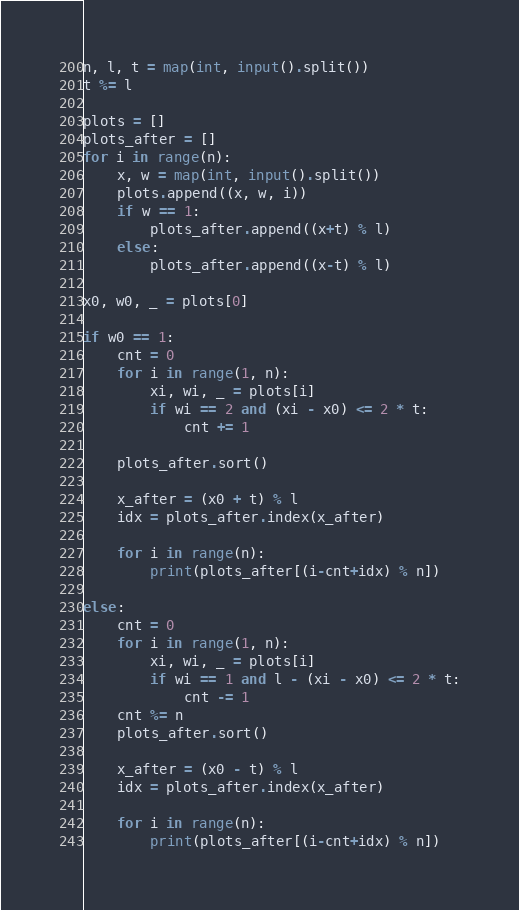Convert code to text. <code><loc_0><loc_0><loc_500><loc_500><_Python_>n, l, t = map(int, input().split())
t %= l

plots = []
plots_after = []
for i in range(n):
    x, w = map(int, input().split())
    plots.append((x, w, i))
    if w == 1:
        plots_after.append((x+t) % l)
    else:
        plots_after.append((x-t) % l)
    
x0, w0, _ = plots[0]

if w0 == 1:
    cnt = 0
    for i in range(1, n):
        xi, wi, _ = plots[i]
        if wi == 2 and (xi - x0) <= 2 * t:
            cnt += 1

    plots_after.sort()

    x_after = (x0 + t) % l
    idx = plots_after.index(x_after)

    for i in range(n):
        print(plots_after[(i-cnt+idx) % n])

else:
    cnt = 0
    for i in range(1, n):
        xi, wi, _ = plots[i]
        if wi == 1 and l - (xi - x0) <= 2 * t:
            cnt -= 1
    cnt %= n
    plots_after.sort()

    x_after = (x0 - t) % l
    idx = plots_after.index(x_after)

    for i in range(n):
        print(plots_after[(i-cnt+idx) % n])</code> 